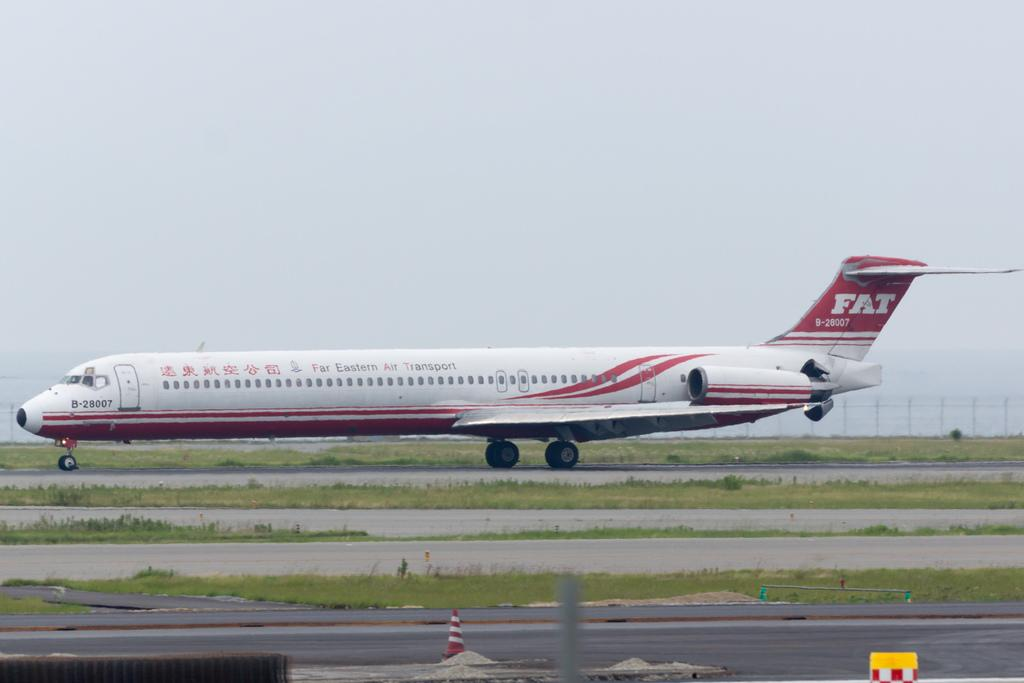<image>
Write a terse but informative summary of the picture. A Far Eastern Air Transport plane with call sign B-28007. 